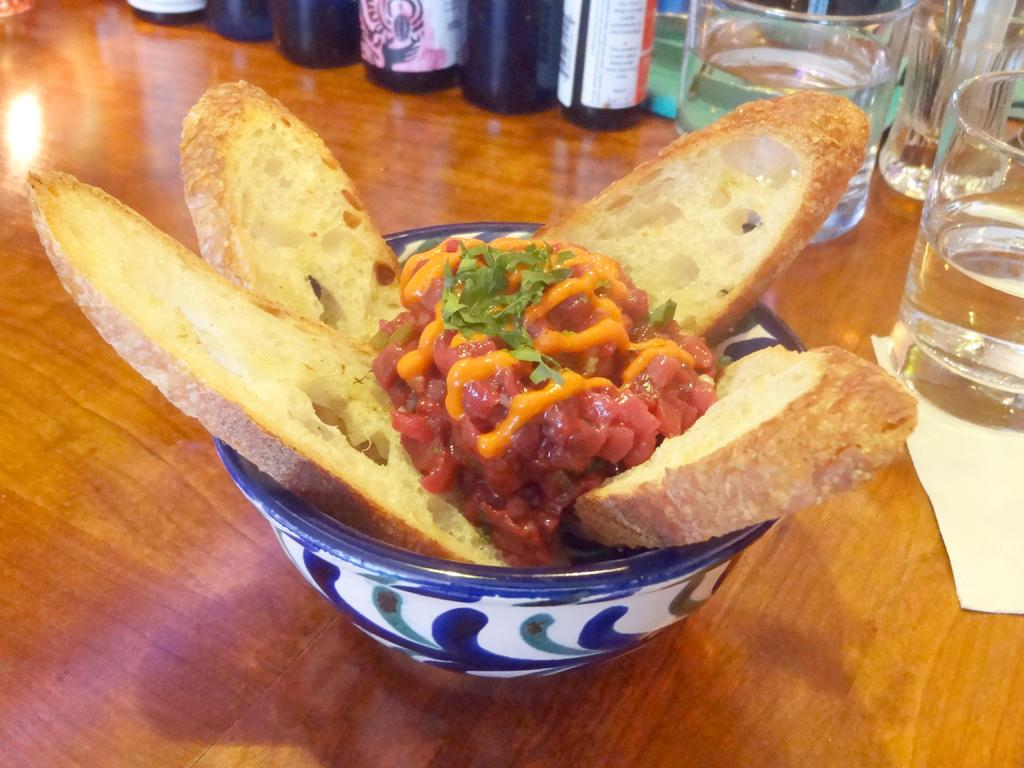What type of containers are holding food items in the image? There are bowls holding food items in the image. What other types of containers are visible in the image? There are glasses and bottles visible in the image. What might be used for wiping or drying hands in the image? There is a paper napkin in the image for wiping or drying hands. What is the surface made of that the objects are placed on? The objects are placed on a wooden surface. What type of stitch is used to hold the bun together in the image? There is no bun present in the image, and therefore no stitch can be observed. What season is depicted in the image with the presence of spring flowers? There is no mention of spring flowers or any seasonal elements in the image. 